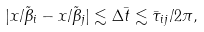<formula> <loc_0><loc_0><loc_500><loc_500>| x / \tilde { \beta } _ { i } - x / \tilde { \beta } _ { j } | \lesssim \Delta \bar { t } \lesssim \bar { \tau } _ { i j } / 2 \pi ,</formula> 